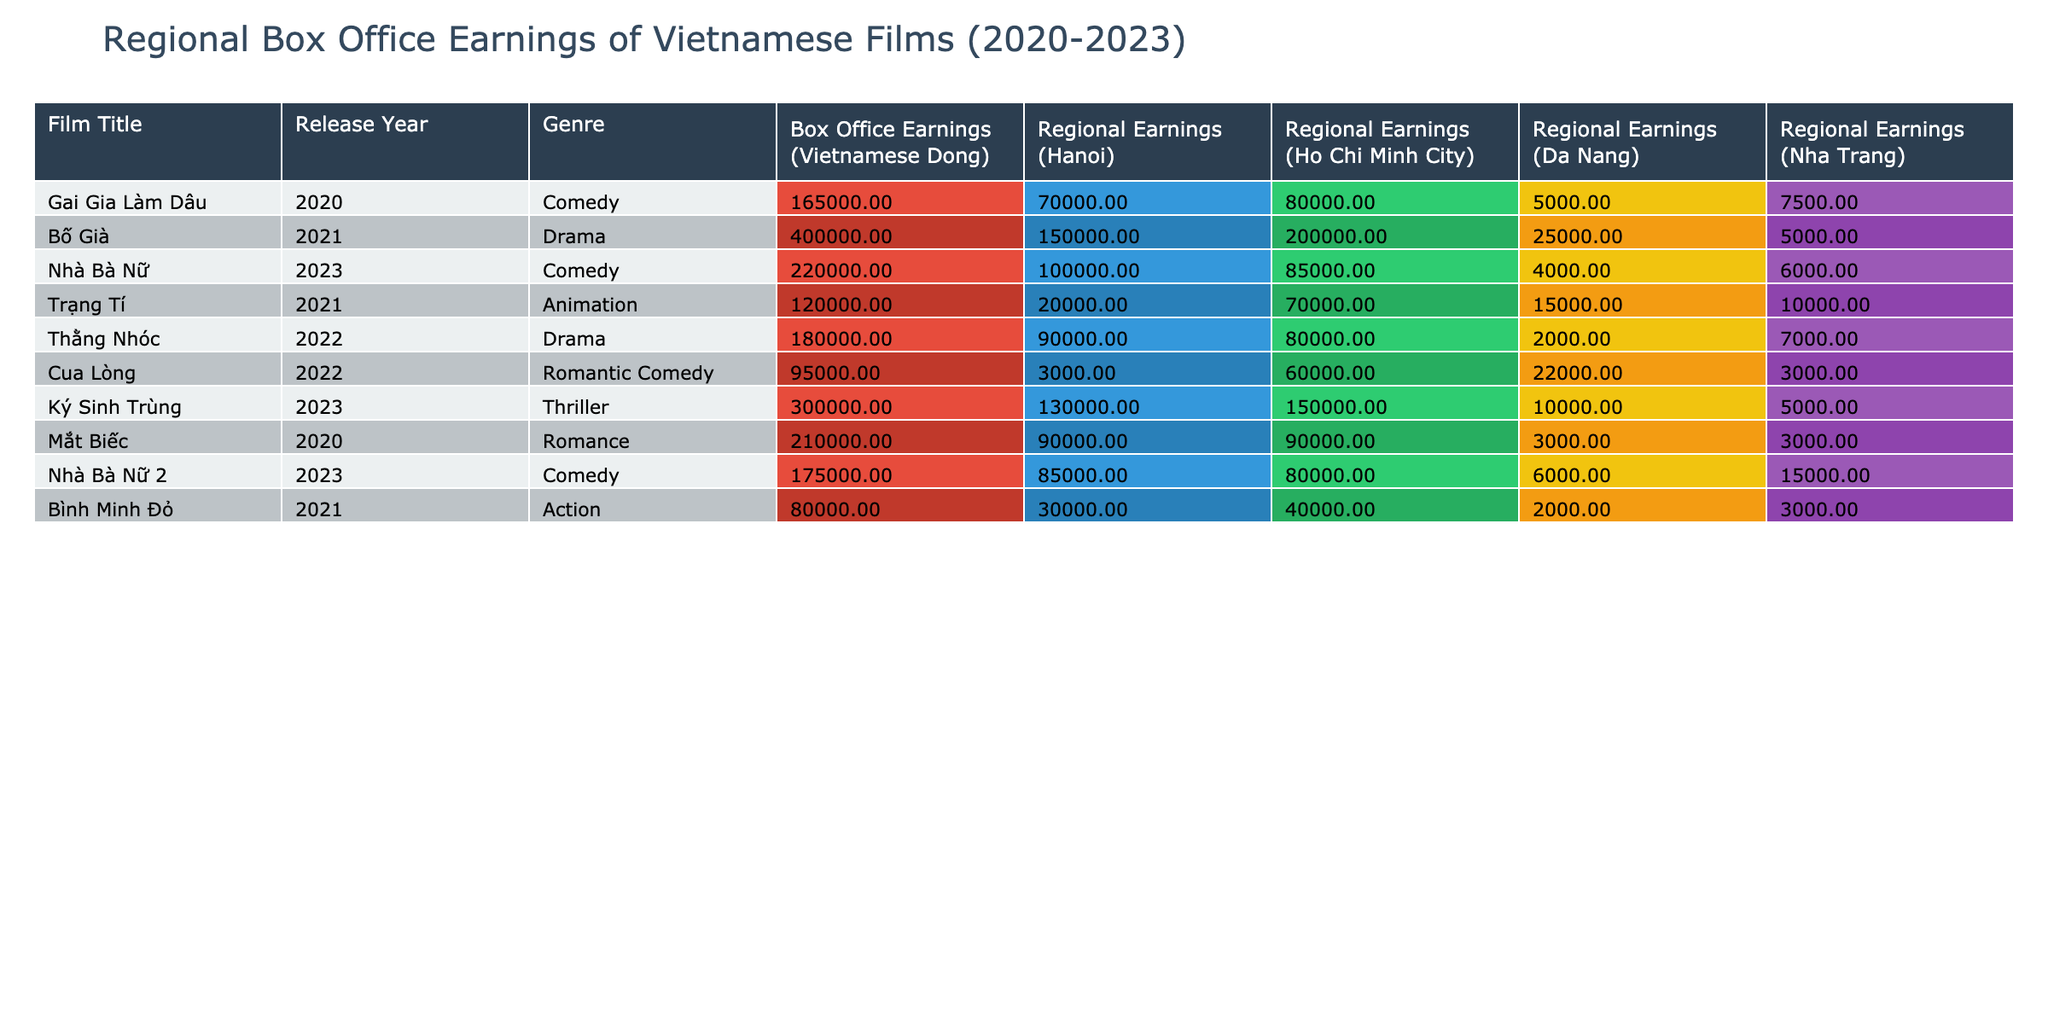What is the box office earnings of the film "Bố Già"? The box office earnings for "Bố Già" is listed under the "Box Office Earnings" column. Referring to the table, the value for "Bố Già" shows 400,000,000,000 Vietnamese Dong.
Answer: 400,000,000,000 Which film had the highest regional earnings in Ho Chi Minh City? To find the film with the highest regional earnings in Ho Chi Minh City, we look at the "Regional Earnings (Ho Chi Minh City)" column and identify the maximum value. "Bố Già" has the highest earnings at 200,000,000,000 Vietnamese Dong.
Answer: Bố Già What is the average regional earnings in Hanoi for the films listed? First, we sum the earnings in the "Regional Earnings (Hanoi)" column: 70,000,000,000 + 150,000,000,000 + 100,000,000,000 + 20,000,000,000 + 90,000,000,000 + 3,000,000,000 + 130,000,000,000 + 85,000,000,000 = 650,000,000,000. There are 8 films, so the average is 650,000,000,000 / 8 = 81,250,000,000.
Answer: 81,250,000,000 Is "Ký Sinh Trùng" a Comedy film? "Ký Sinh Trùng" is classified under the "Genre" column, and it is listed as a Thriller. Therefore, the answer is no.
Answer: No Compare the total regional earnings from Da Nang and Nha Trang for "Nhà Bà Nữ" and "Nhà Bà Nữ 2". Which city contributed more to total earnings? For "Nhà Bà Nữ," Da Nang earnings are 4,000,000,000 and Nha Trang earnings are 6,000,000,000, totaling 10,000,000,000. For "Nhà Bà Nữ 2," Da Nang is 6,000,000,000 and Nha Trang is 15,000,000,000, totaling 21,000,000,000. The contributions add up to 10,000,000,000 (Da Nang) + 6,000,000,000 (Nha Trang) = 16,000,000,000 for "Nhà Bà Nữ," while for "Nhà Bà Nữ 2," it’s 21,000,000,000. Hence, "Nhà Bà Nữ 2" had more earnings from these cities.
Answer: Nhà Bà Nữ 2 contributed more What is the difference in box office earnings between the films "Gai Gia Làm Dâu" and "Thằng Nhóc"? The box office earnings for "Gai Gia Làm Dâu" is 165,000,000,000 and for "Thằng Nhóc," it is 180,000,000,000. The difference is calculated as 180,000,000,000 - 165,000,000,000 = 15,000,000,000.
Answer: 15,000,000,000 